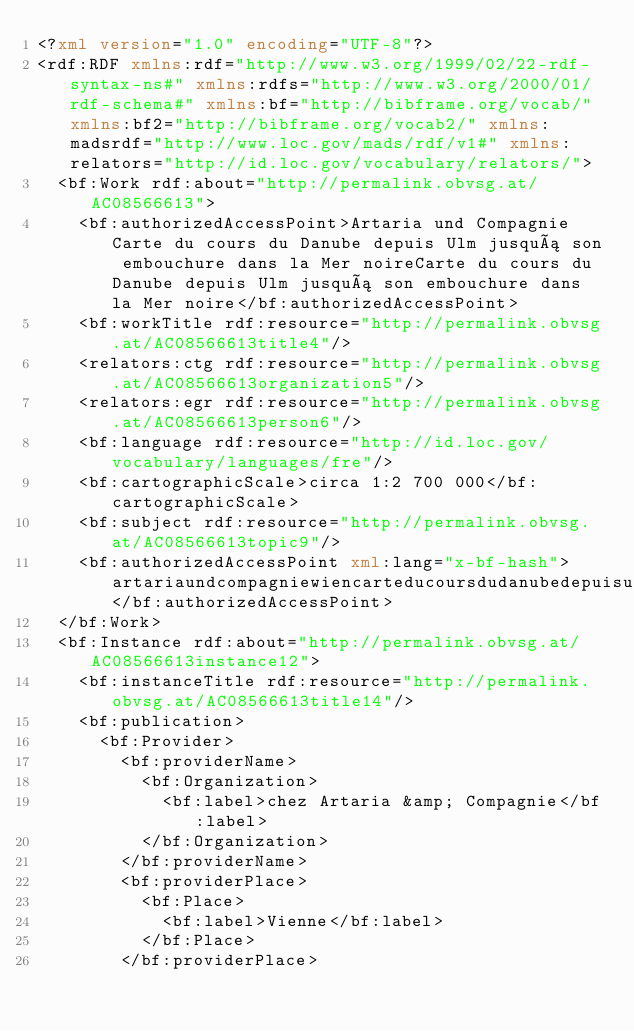Convert code to text. <code><loc_0><loc_0><loc_500><loc_500><_XML_><?xml version="1.0" encoding="UTF-8"?>
<rdf:RDF xmlns:rdf="http://www.w3.org/1999/02/22-rdf-syntax-ns#" xmlns:rdfs="http://www.w3.org/2000/01/rdf-schema#" xmlns:bf="http://bibframe.org/vocab/" xmlns:bf2="http://bibframe.org/vocab2/" xmlns:madsrdf="http://www.loc.gov/mads/rdf/v1#" xmlns:relators="http://id.loc.gov/vocabulary/relators/">
  <bf:Work rdf:about="http://permalink.obvsg.at/AC08566613">
    <bf:authorizedAccessPoint>Artaria und Compagnie Carte du cours du Danube depuis Ulm jusquá son embouchure dans la Mer noireCarte du cours du Danube depuis Ulm jusquá son embouchure dans la Mer noire</bf:authorizedAccessPoint>
    <bf:workTitle rdf:resource="http://permalink.obvsg.at/AC08566613title4"/>
    <relators:ctg rdf:resource="http://permalink.obvsg.at/AC08566613organization5"/>
    <relators:egr rdf:resource="http://permalink.obvsg.at/AC08566613person6"/>
    <bf:language rdf:resource="http://id.loc.gov/vocabulary/languages/fre"/>
    <bf:cartographicScale>circa 1:2 700 000</bf:cartographicScale>
    <bf:subject rdf:resource="http://permalink.obvsg.at/AC08566613topic9"/>
    <bf:authorizedAccessPoint xml:lang="x-bf-hash">artariaundcompagniewiencarteducoursdudanubedepuisulmjusquásonembouchuredanslamernoirework</bf:authorizedAccessPoint>
  </bf:Work>
  <bf:Instance rdf:about="http://permalink.obvsg.at/AC08566613instance12">
    <bf:instanceTitle rdf:resource="http://permalink.obvsg.at/AC08566613title14"/>
    <bf:publication>
      <bf:Provider>
        <bf:providerName>
          <bf:Organization>
            <bf:label>chez Artaria &amp; Compagnie</bf:label>
          </bf:Organization>
        </bf:providerName>
        <bf:providerPlace>
          <bf:Place>
            <bf:label>Vienne</bf:label>
          </bf:Place>
        </bf:providerPlace></code> 